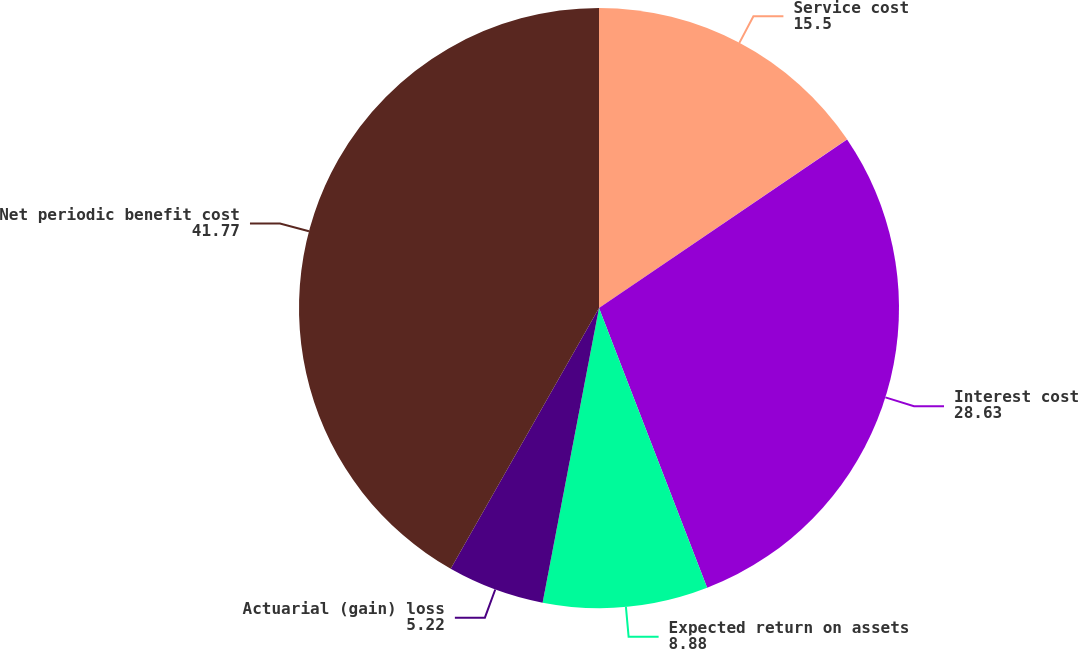<chart> <loc_0><loc_0><loc_500><loc_500><pie_chart><fcel>Service cost<fcel>Interest cost<fcel>Expected return on assets<fcel>Actuarial (gain) loss<fcel>Net periodic benefit cost<nl><fcel>15.5%<fcel>28.63%<fcel>8.88%<fcel>5.22%<fcel>41.77%<nl></chart> 